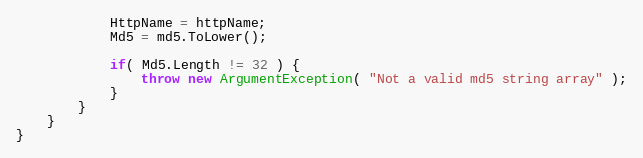<code> <loc_0><loc_0><loc_500><loc_500><_C#_>            HttpName = httpName;
            Md5 = md5.ToLower();

            if( Md5.Length != 32 ) {
                throw new ArgumentException( "Not a valid md5 string array" );
            }
        }
    }
}</code> 